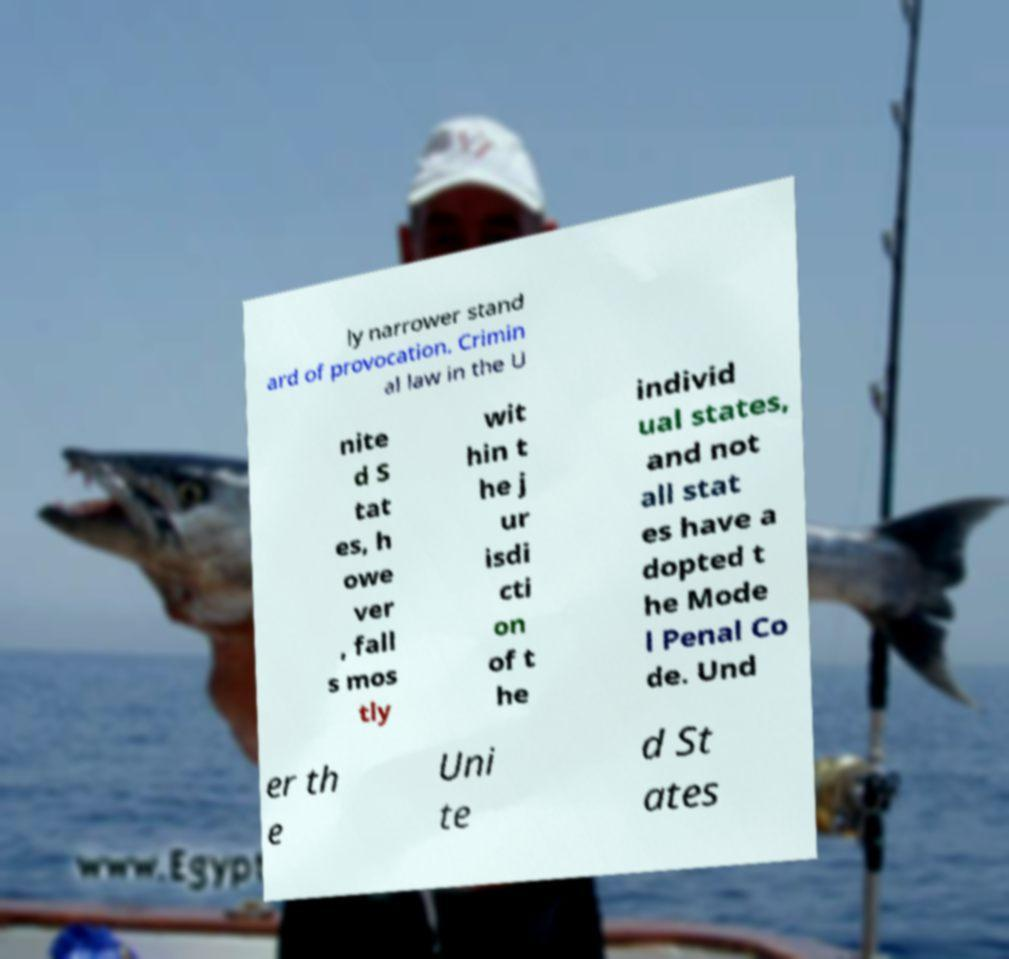Please identify and transcribe the text found in this image. ly narrower stand ard of provocation. Crimin al law in the U nite d S tat es, h owe ver , fall s mos tly wit hin t he j ur isdi cti on of t he individ ual states, and not all stat es have a dopted t he Mode l Penal Co de. Und er th e Uni te d St ates 